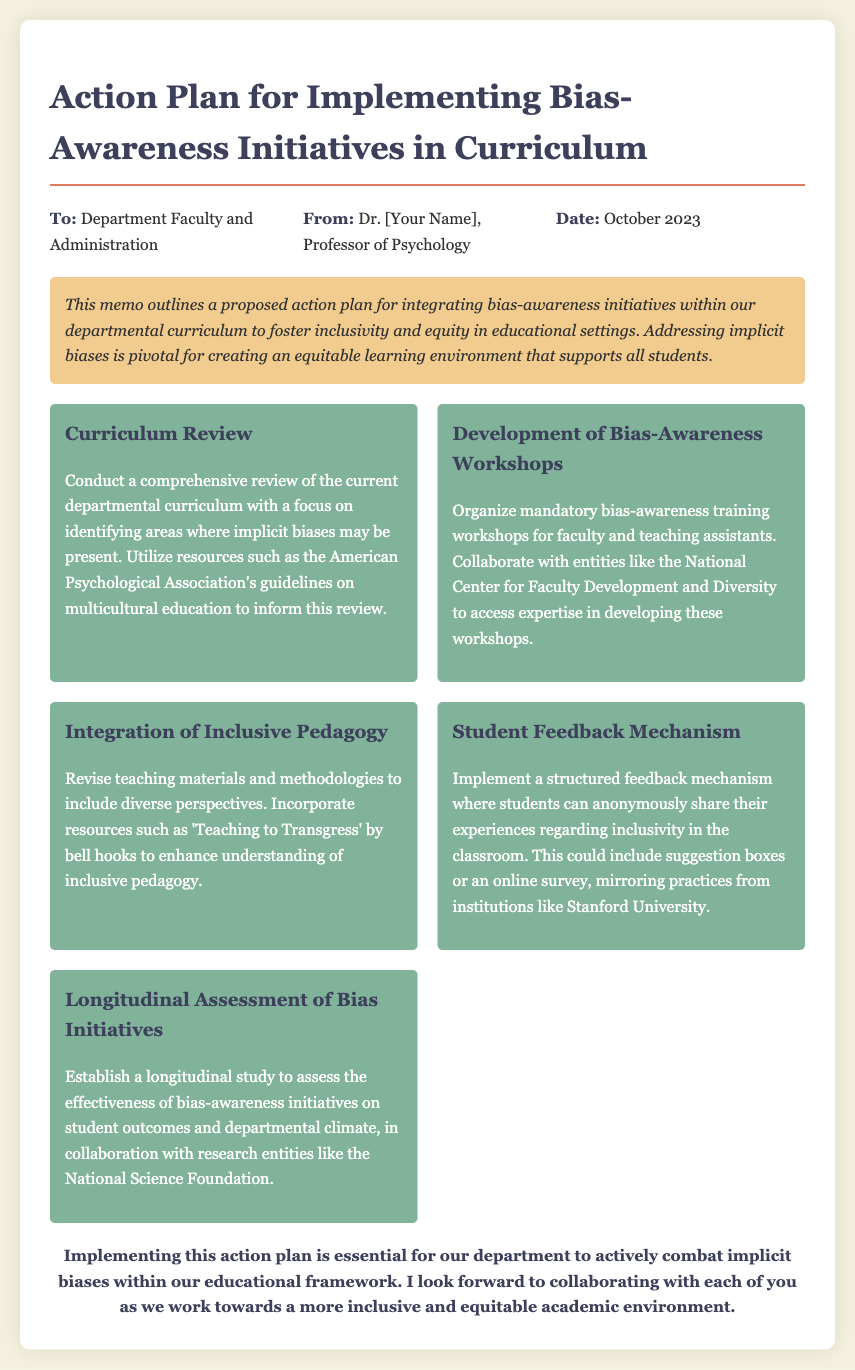What is the title of the memo? The title is explicitly stated at the beginning of the document as the main heading.
Answer: Action Plan for Implementing Bias-Awareness Initiatives in Curriculum Who is the memo addressed to? The memo includes a "To:" section specifying the recipients' details.
Answer: Department Faculty and Administration What is the date of the memo? The date is clearly indicated in the header section of the document.
Answer: October 2023 What initiative includes a review of the current curriculum? The document outlines specific initiatives and the one pertaining to curriculum review is mentioned directly.
Answer: Curriculum Review Which book is recommended for understanding inclusive pedagogy? The memo cites a book as a resource for revising teaching materials, which helps in identifying diversity.
Answer: Teaching to Transgress What is one method proposed for student feedback? The document suggests specific feedback mechanisms for students to share their experiences.
Answer: Suggestion boxes What research entity is mentioned for collaboration on assessing initiatives? The memo lists various entities to collaborate with, one of which is specified in the context of assessment.
Answer: National Science Foundation How many action items are listed in the memo? The total number of action items can be counted in the action-items section of the document.
Answer: Five 